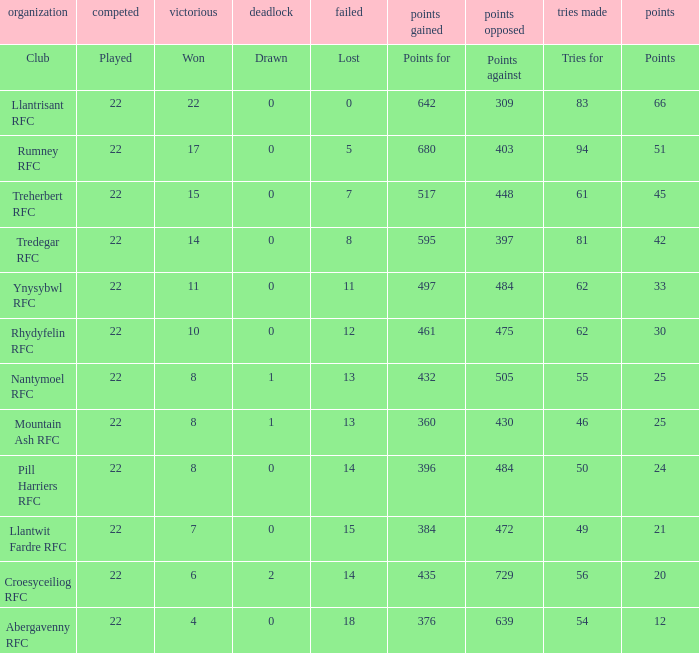How many matches were won by the teams that scored exactly 61 tries for? 15.0. 